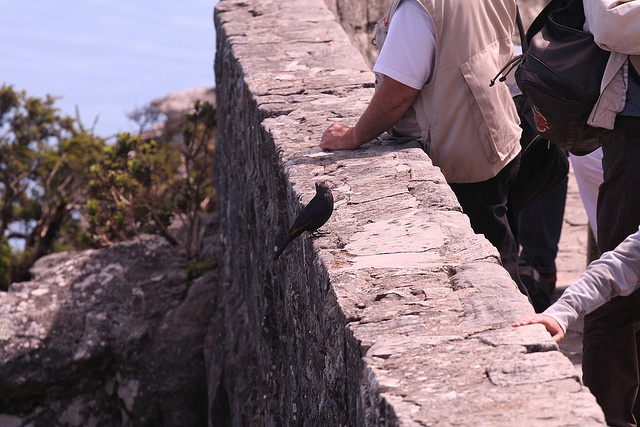Describe the objects in this image and their specific colors. I can see people in lavender, brown, black, gray, and maroon tones, backpack in lavender, black, maroon, gray, and darkgray tones, people in lavender, black, and gray tones, people in lavender, gray, pink, and darkgray tones, and bird in lavender, black, gray, and darkgray tones in this image. 